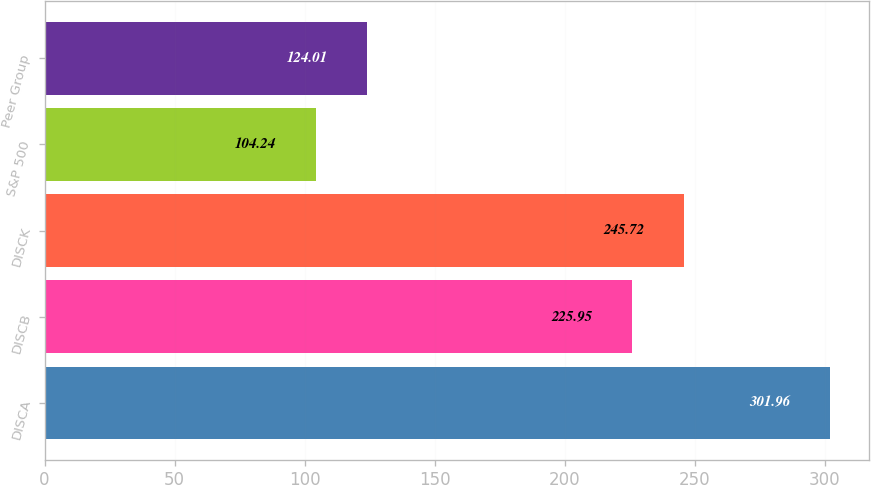<chart> <loc_0><loc_0><loc_500><loc_500><bar_chart><fcel>DISCA<fcel>DISCB<fcel>DISCK<fcel>S&P 500<fcel>Peer Group<nl><fcel>301.96<fcel>225.95<fcel>245.72<fcel>104.24<fcel>124.01<nl></chart> 